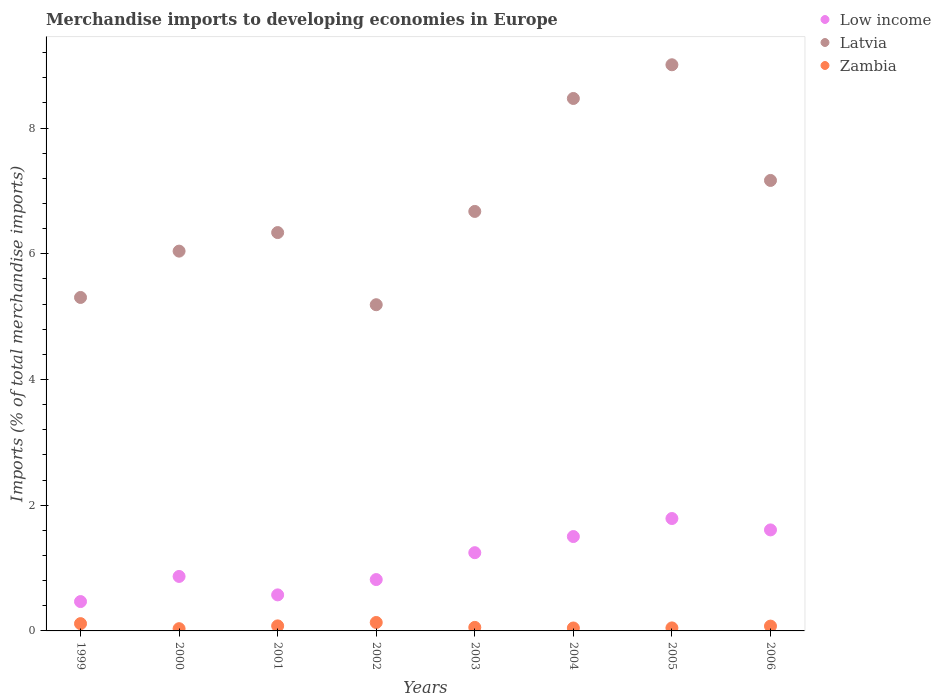Is the number of dotlines equal to the number of legend labels?
Make the answer very short. Yes. What is the percentage total merchandise imports in Latvia in 2005?
Provide a short and direct response. 9.01. Across all years, what is the maximum percentage total merchandise imports in Zambia?
Provide a succinct answer. 0.13. Across all years, what is the minimum percentage total merchandise imports in Low income?
Your answer should be very brief. 0.47. In which year was the percentage total merchandise imports in Low income minimum?
Give a very brief answer. 1999. What is the total percentage total merchandise imports in Low income in the graph?
Offer a terse response. 8.87. What is the difference between the percentage total merchandise imports in Latvia in 2001 and that in 2003?
Provide a succinct answer. -0.34. What is the difference between the percentage total merchandise imports in Zambia in 2002 and the percentage total merchandise imports in Low income in 2005?
Your answer should be compact. -1.65. What is the average percentage total merchandise imports in Latvia per year?
Your answer should be very brief. 6.77. In the year 1999, what is the difference between the percentage total merchandise imports in Latvia and percentage total merchandise imports in Low income?
Make the answer very short. 4.84. In how many years, is the percentage total merchandise imports in Zambia greater than 4.8 %?
Offer a very short reply. 0. What is the ratio of the percentage total merchandise imports in Latvia in 2002 to that in 2006?
Your answer should be compact. 0.72. What is the difference between the highest and the second highest percentage total merchandise imports in Low income?
Keep it short and to the point. 0.18. What is the difference between the highest and the lowest percentage total merchandise imports in Zambia?
Offer a very short reply. 0.1. In how many years, is the percentage total merchandise imports in Low income greater than the average percentage total merchandise imports in Low income taken over all years?
Your answer should be very brief. 4. Is the percentage total merchandise imports in Zambia strictly less than the percentage total merchandise imports in Low income over the years?
Keep it short and to the point. Yes. How many dotlines are there?
Keep it short and to the point. 3. How many years are there in the graph?
Make the answer very short. 8. What is the difference between two consecutive major ticks on the Y-axis?
Keep it short and to the point. 2. Are the values on the major ticks of Y-axis written in scientific E-notation?
Give a very brief answer. No. Does the graph contain any zero values?
Offer a very short reply. No. How are the legend labels stacked?
Provide a short and direct response. Vertical. What is the title of the graph?
Offer a very short reply. Merchandise imports to developing economies in Europe. What is the label or title of the Y-axis?
Your answer should be very brief. Imports (% of total merchandise imports). What is the Imports (% of total merchandise imports) of Low income in 1999?
Ensure brevity in your answer.  0.47. What is the Imports (% of total merchandise imports) in Latvia in 1999?
Ensure brevity in your answer.  5.31. What is the Imports (% of total merchandise imports) of Zambia in 1999?
Your answer should be very brief. 0.12. What is the Imports (% of total merchandise imports) in Low income in 2000?
Make the answer very short. 0.87. What is the Imports (% of total merchandise imports) in Latvia in 2000?
Keep it short and to the point. 6.04. What is the Imports (% of total merchandise imports) in Zambia in 2000?
Make the answer very short. 0.04. What is the Imports (% of total merchandise imports) in Low income in 2001?
Provide a short and direct response. 0.57. What is the Imports (% of total merchandise imports) of Latvia in 2001?
Make the answer very short. 6.34. What is the Imports (% of total merchandise imports) of Zambia in 2001?
Your answer should be compact. 0.08. What is the Imports (% of total merchandise imports) of Low income in 2002?
Offer a very short reply. 0.82. What is the Imports (% of total merchandise imports) of Latvia in 2002?
Ensure brevity in your answer.  5.19. What is the Imports (% of total merchandise imports) of Zambia in 2002?
Provide a short and direct response. 0.13. What is the Imports (% of total merchandise imports) in Low income in 2003?
Keep it short and to the point. 1.24. What is the Imports (% of total merchandise imports) of Latvia in 2003?
Make the answer very short. 6.67. What is the Imports (% of total merchandise imports) in Zambia in 2003?
Ensure brevity in your answer.  0.06. What is the Imports (% of total merchandise imports) of Low income in 2004?
Your answer should be very brief. 1.5. What is the Imports (% of total merchandise imports) of Latvia in 2004?
Offer a very short reply. 8.47. What is the Imports (% of total merchandise imports) of Zambia in 2004?
Provide a short and direct response. 0.05. What is the Imports (% of total merchandise imports) of Low income in 2005?
Offer a terse response. 1.79. What is the Imports (% of total merchandise imports) in Latvia in 2005?
Your answer should be very brief. 9.01. What is the Imports (% of total merchandise imports) in Zambia in 2005?
Your response must be concise. 0.05. What is the Imports (% of total merchandise imports) of Low income in 2006?
Your answer should be compact. 1.61. What is the Imports (% of total merchandise imports) in Latvia in 2006?
Offer a terse response. 7.17. What is the Imports (% of total merchandise imports) of Zambia in 2006?
Give a very brief answer. 0.08. Across all years, what is the maximum Imports (% of total merchandise imports) of Low income?
Your answer should be compact. 1.79. Across all years, what is the maximum Imports (% of total merchandise imports) in Latvia?
Give a very brief answer. 9.01. Across all years, what is the maximum Imports (% of total merchandise imports) of Zambia?
Make the answer very short. 0.13. Across all years, what is the minimum Imports (% of total merchandise imports) of Low income?
Keep it short and to the point. 0.47. Across all years, what is the minimum Imports (% of total merchandise imports) of Latvia?
Make the answer very short. 5.19. Across all years, what is the minimum Imports (% of total merchandise imports) in Zambia?
Your answer should be very brief. 0.04. What is the total Imports (% of total merchandise imports) in Low income in the graph?
Give a very brief answer. 8.87. What is the total Imports (% of total merchandise imports) of Latvia in the graph?
Ensure brevity in your answer.  54.19. What is the total Imports (% of total merchandise imports) of Zambia in the graph?
Make the answer very short. 0.59. What is the difference between the Imports (% of total merchandise imports) in Low income in 1999 and that in 2000?
Provide a short and direct response. -0.4. What is the difference between the Imports (% of total merchandise imports) of Latvia in 1999 and that in 2000?
Offer a very short reply. -0.74. What is the difference between the Imports (% of total merchandise imports) in Zambia in 1999 and that in 2000?
Provide a succinct answer. 0.08. What is the difference between the Imports (% of total merchandise imports) of Low income in 1999 and that in 2001?
Give a very brief answer. -0.11. What is the difference between the Imports (% of total merchandise imports) in Latvia in 1999 and that in 2001?
Your answer should be compact. -1.03. What is the difference between the Imports (% of total merchandise imports) in Zambia in 1999 and that in 2001?
Offer a terse response. 0.04. What is the difference between the Imports (% of total merchandise imports) in Low income in 1999 and that in 2002?
Keep it short and to the point. -0.35. What is the difference between the Imports (% of total merchandise imports) of Latvia in 1999 and that in 2002?
Your answer should be compact. 0.12. What is the difference between the Imports (% of total merchandise imports) in Zambia in 1999 and that in 2002?
Your answer should be very brief. -0.02. What is the difference between the Imports (% of total merchandise imports) in Low income in 1999 and that in 2003?
Give a very brief answer. -0.78. What is the difference between the Imports (% of total merchandise imports) of Latvia in 1999 and that in 2003?
Offer a terse response. -1.37. What is the difference between the Imports (% of total merchandise imports) in Zambia in 1999 and that in 2003?
Ensure brevity in your answer.  0.06. What is the difference between the Imports (% of total merchandise imports) in Low income in 1999 and that in 2004?
Your response must be concise. -1.03. What is the difference between the Imports (% of total merchandise imports) of Latvia in 1999 and that in 2004?
Your answer should be compact. -3.17. What is the difference between the Imports (% of total merchandise imports) in Zambia in 1999 and that in 2004?
Provide a succinct answer. 0.07. What is the difference between the Imports (% of total merchandise imports) in Low income in 1999 and that in 2005?
Provide a succinct answer. -1.32. What is the difference between the Imports (% of total merchandise imports) in Latvia in 1999 and that in 2005?
Provide a short and direct response. -3.7. What is the difference between the Imports (% of total merchandise imports) of Zambia in 1999 and that in 2005?
Your answer should be very brief. 0.07. What is the difference between the Imports (% of total merchandise imports) of Low income in 1999 and that in 2006?
Offer a very short reply. -1.14. What is the difference between the Imports (% of total merchandise imports) in Latvia in 1999 and that in 2006?
Give a very brief answer. -1.86. What is the difference between the Imports (% of total merchandise imports) in Zambia in 1999 and that in 2006?
Your answer should be very brief. 0.04. What is the difference between the Imports (% of total merchandise imports) of Low income in 2000 and that in 2001?
Provide a succinct answer. 0.29. What is the difference between the Imports (% of total merchandise imports) of Latvia in 2000 and that in 2001?
Make the answer very short. -0.3. What is the difference between the Imports (% of total merchandise imports) in Zambia in 2000 and that in 2001?
Give a very brief answer. -0.04. What is the difference between the Imports (% of total merchandise imports) in Low income in 2000 and that in 2002?
Provide a short and direct response. 0.05. What is the difference between the Imports (% of total merchandise imports) of Latvia in 2000 and that in 2002?
Your answer should be very brief. 0.85. What is the difference between the Imports (% of total merchandise imports) of Zambia in 2000 and that in 2002?
Offer a terse response. -0.1. What is the difference between the Imports (% of total merchandise imports) in Low income in 2000 and that in 2003?
Your response must be concise. -0.38. What is the difference between the Imports (% of total merchandise imports) in Latvia in 2000 and that in 2003?
Provide a succinct answer. -0.63. What is the difference between the Imports (% of total merchandise imports) in Zambia in 2000 and that in 2003?
Give a very brief answer. -0.02. What is the difference between the Imports (% of total merchandise imports) of Low income in 2000 and that in 2004?
Provide a short and direct response. -0.63. What is the difference between the Imports (% of total merchandise imports) of Latvia in 2000 and that in 2004?
Your response must be concise. -2.43. What is the difference between the Imports (% of total merchandise imports) of Zambia in 2000 and that in 2004?
Your response must be concise. -0.01. What is the difference between the Imports (% of total merchandise imports) of Low income in 2000 and that in 2005?
Your answer should be compact. -0.92. What is the difference between the Imports (% of total merchandise imports) in Latvia in 2000 and that in 2005?
Provide a short and direct response. -2.96. What is the difference between the Imports (% of total merchandise imports) of Zambia in 2000 and that in 2005?
Offer a very short reply. -0.01. What is the difference between the Imports (% of total merchandise imports) in Low income in 2000 and that in 2006?
Your answer should be very brief. -0.74. What is the difference between the Imports (% of total merchandise imports) in Latvia in 2000 and that in 2006?
Give a very brief answer. -1.12. What is the difference between the Imports (% of total merchandise imports) in Zambia in 2000 and that in 2006?
Ensure brevity in your answer.  -0.04. What is the difference between the Imports (% of total merchandise imports) in Low income in 2001 and that in 2002?
Offer a very short reply. -0.24. What is the difference between the Imports (% of total merchandise imports) of Latvia in 2001 and that in 2002?
Your response must be concise. 1.15. What is the difference between the Imports (% of total merchandise imports) of Zambia in 2001 and that in 2002?
Provide a succinct answer. -0.05. What is the difference between the Imports (% of total merchandise imports) in Low income in 2001 and that in 2003?
Ensure brevity in your answer.  -0.67. What is the difference between the Imports (% of total merchandise imports) in Latvia in 2001 and that in 2003?
Provide a short and direct response. -0.34. What is the difference between the Imports (% of total merchandise imports) in Zambia in 2001 and that in 2003?
Give a very brief answer. 0.02. What is the difference between the Imports (% of total merchandise imports) in Low income in 2001 and that in 2004?
Your answer should be very brief. -0.93. What is the difference between the Imports (% of total merchandise imports) of Latvia in 2001 and that in 2004?
Give a very brief answer. -2.13. What is the difference between the Imports (% of total merchandise imports) of Zambia in 2001 and that in 2004?
Make the answer very short. 0.03. What is the difference between the Imports (% of total merchandise imports) of Low income in 2001 and that in 2005?
Offer a very short reply. -1.22. What is the difference between the Imports (% of total merchandise imports) in Latvia in 2001 and that in 2005?
Ensure brevity in your answer.  -2.67. What is the difference between the Imports (% of total merchandise imports) of Zambia in 2001 and that in 2005?
Keep it short and to the point. 0.03. What is the difference between the Imports (% of total merchandise imports) in Low income in 2001 and that in 2006?
Keep it short and to the point. -1.03. What is the difference between the Imports (% of total merchandise imports) in Latvia in 2001 and that in 2006?
Ensure brevity in your answer.  -0.83. What is the difference between the Imports (% of total merchandise imports) in Zambia in 2001 and that in 2006?
Give a very brief answer. 0. What is the difference between the Imports (% of total merchandise imports) in Low income in 2002 and that in 2003?
Your response must be concise. -0.43. What is the difference between the Imports (% of total merchandise imports) of Latvia in 2002 and that in 2003?
Your answer should be very brief. -1.48. What is the difference between the Imports (% of total merchandise imports) in Zambia in 2002 and that in 2003?
Offer a terse response. 0.08. What is the difference between the Imports (% of total merchandise imports) in Low income in 2002 and that in 2004?
Provide a succinct answer. -0.68. What is the difference between the Imports (% of total merchandise imports) in Latvia in 2002 and that in 2004?
Your answer should be compact. -3.28. What is the difference between the Imports (% of total merchandise imports) in Zambia in 2002 and that in 2004?
Offer a very short reply. 0.09. What is the difference between the Imports (% of total merchandise imports) in Low income in 2002 and that in 2005?
Ensure brevity in your answer.  -0.97. What is the difference between the Imports (% of total merchandise imports) of Latvia in 2002 and that in 2005?
Your answer should be compact. -3.82. What is the difference between the Imports (% of total merchandise imports) of Zambia in 2002 and that in 2005?
Offer a very short reply. 0.09. What is the difference between the Imports (% of total merchandise imports) in Low income in 2002 and that in 2006?
Offer a very short reply. -0.79. What is the difference between the Imports (% of total merchandise imports) of Latvia in 2002 and that in 2006?
Ensure brevity in your answer.  -1.98. What is the difference between the Imports (% of total merchandise imports) of Zambia in 2002 and that in 2006?
Make the answer very short. 0.06. What is the difference between the Imports (% of total merchandise imports) in Low income in 2003 and that in 2004?
Offer a very short reply. -0.26. What is the difference between the Imports (% of total merchandise imports) in Latvia in 2003 and that in 2004?
Offer a terse response. -1.8. What is the difference between the Imports (% of total merchandise imports) in Zambia in 2003 and that in 2004?
Keep it short and to the point. 0.01. What is the difference between the Imports (% of total merchandise imports) of Low income in 2003 and that in 2005?
Provide a short and direct response. -0.54. What is the difference between the Imports (% of total merchandise imports) in Latvia in 2003 and that in 2005?
Offer a very short reply. -2.33. What is the difference between the Imports (% of total merchandise imports) of Zambia in 2003 and that in 2005?
Your answer should be compact. 0.01. What is the difference between the Imports (% of total merchandise imports) of Low income in 2003 and that in 2006?
Give a very brief answer. -0.36. What is the difference between the Imports (% of total merchandise imports) of Latvia in 2003 and that in 2006?
Make the answer very short. -0.49. What is the difference between the Imports (% of total merchandise imports) in Zambia in 2003 and that in 2006?
Make the answer very short. -0.02. What is the difference between the Imports (% of total merchandise imports) in Low income in 2004 and that in 2005?
Your answer should be very brief. -0.29. What is the difference between the Imports (% of total merchandise imports) of Latvia in 2004 and that in 2005?
Your response must be concise. -0.54. What is the difference between the Imports (% of total merchandise imports) of Zambia in 2004 and that in 2005?
Your answer should be compact. -0. What is the difference between the Imports (% of total merchandise imports) in Low income in 2004 and that in 2006?
Provide a succinct answer. -0.11. What is the difference between the Imports (% of total merchandise imports) of Latvia in 2004 and that in 2006?
Your answer should be very brief. 1.3. What is the difference between the Imports (% of total merchandise imports) of Zambia in 2004 and that in 2006?
Your response must be concise. -0.03. What is the difference between the Imports (% of total merchandise imports) of Low income in 2005 and that in 2006?
Provide a succinct answer. 0.18. What is the difference between the Imports (% of total merchandise imports) of Latvia in 2005 and that in 2006?
Make the answer very short. 1.84. What is the difference between the Imports (% of total merchandise imports) in Zambia in 2005 and that in 2006?
Make the answer very short. -0.03. What is the difference between the Imports (% of total merchandise imports) in Low income in 1999 and the Imports (% of total merchandise imports) in Latvia in 2000?
Provide a succinct answer. -5.58. What is the difference between the Imports (% of total merchandise imports) of Low income in 1999 and the Imports (% of total merchandise imports) of Zambia in 2000?
Offer a very short reply. 0.43. What is the difference between the Imports (% of total merchandise imports) of Latvia in 1999 and the Imports (% of total merchandise imports) of Zambia in 2000?
Offer a terse response. 5.27. What is the difference between the Imports (% of total merchandise imports) of Low income in 1999 and the Imports (% of total merchandise imports) of Latvia in 2001?
Give a very brief answer. -5.87. What is the difference between the Imports (% of total merchandise imports) of Low income in 1999 and the Imports (% of total merchandise imports) of Zambia in 2001?
Provide a short and direct response. 0.39. What is the difference between the Imports (% of total merchandise imports) in Latvia in 1999 and the Imports (% of total merchandise imports) in Zambia in 2001?
Give a very brief answer. 5.23. What is the difference between the Imports (% of total merchandise imports) in Low income in 1999 and the Imports (% of total merchandise imports) in Latvia in 2002?
Provide a succinct answer. -4.72. What is the difference between the Imports (% of total merchandise imports) in Low income in 1999 and the Imports (% of total merchandise imports) in Zambia in 2002?
Ensure brevity in your answer.  0.33. What is the difference between the Imports (% of total merchandise imports) in Latvia in 1999 and the Imports (% of total merchandise imports) in Zambia in 2002?
Give a very brief answer. 5.17. What is the difference between the Imports (% of total merchandise imports) in Low income in 1999 and the Imports (% of total merchandise imports) in Latvia in 2003?
Offer a very short reply. -6.21. What is the difference between the Imports (% of total merchandise imports) of Low income in 1999 and the Imports (% of total merchandise imports) of Zambia in 2003?
Your answer should be compact. 0.41. What is the difference between the Imports (% of total merchandise imports) of Latvia in 1999 and the Imports (% of total merchandise imports) of Zambia in 2003?
Give a very brief answer. 5.25. What is the difference between the Imports (% of total merchandise imports) in Low income in 1999 and the Imports (% of total merchandise imports) in Latvia in 2004?
Make the answer very short. -8. What is the difference between the Imports (% of total merchandise imports) in Low income in 1999 and the Imports (% of total merchandise imports) in Zambia in 2004?
Offer a terse response. 0.42. What is the difference between the Imports (% of total merchandise imports) in Latvia in 1999 and the Imports (% of total merchandise imports) in Zambia in 2004?
Offer a terse response. 5.26. What is the difference between the Imports (% of total merchandise imports) of Low income in 1999 and the Imports (% of total merchandise imports) of Latvia in 2005?
Ensure brevity in your answer.  -8.54. What is the difference between the Imports (% of total merchandise imports) of Low income in 1999 and the Imports (% of total merchandise imports) of Zambia in 2005?
Ensure brevity in your answer.  0.42. What is the difference between the Imports (% of total merchandise imports) in Latvia in 1999 and the Imports (% of total merchandise imports) in Zambia in 2005?
Your answer should be very brief. 5.26. What is the difference between the Imports (% of total merchandise imports) of Low income in 1999 and the Imports (% of total merchandise imports) of Latvia in 2006?
Your response must be concise. -6.7. What is the difference between the Imports (% of total merchandise imports) in Low income in 1999 and the Imports (% of total merchandise imports) in Zambia in 2006?
Your response must be concise. 0.39. What is the difference between the Imports (% of total merchandise imports) in Latvia in 1999 and the Imports (% of total merchandise imports) in Zambia in 2006?
Keep it short and to the point. 5.23. What is the difference between the Imports (% of total merchandise imports) of Low income in 2000 and the Imports (% of total merchandise imports) of Latvia in 2001?
Offer a very short reply. -5.47. What is the difference between the Imports (% of total merchandise imports) in Low income in 2000 and the Imports (% of total merchandise imports) in Zambia in 2001?
Your answer should be compact. 0.79. What is the difference between the Imports (% of total merchandise imports) in Latvia in 2000 and the Imports (% of total merchandise imports) in Zambia in 2001?
Offer a terse response. 5.96. What is the difference between the Imports (% of total merchandise imports) of Low income in 2000 and the Imports (% of total merchandise imports) of Latvia in 2002?
Your response must be concise. -4.32. What is the difference between the Imports (% of total merchandise imports) of Low income in 2000 and the Imports (% of total merchandise imports) of Zambia in 2002?
Offer a terse response. 0.73. What is the difference between the Imports (% of total merchandise imports) in Latvia in 2000 and the Imports (% of total merchandise imports) in Zambia in 2002?
Ensure brevity in your answer.  5.91. What is the difference between the Imports (% of total merchandise imports) of Low income in 2000 and the Imports (% of total merchandise imports) of Latvia in 2003?
Provide a succinct answer. -5.81. What is the difference between the Imports (% of total merchandise imports) in Low income in 2000 and the Imports (% of total merchandise imports) in Zambia in 2003?
Offer a very short reply. 0.81. What is the difference between the Imports (% of total merchandise imports) in Latvia in 2000 and the Imports (% of total merchandise imports) in Zambia in 2003?
Your answer should be compact. 5.99. What is the difference between the Imports (% of total merchandise imports) in Low income in 2000 and the Imports (% of total merchandise imports) in Latvia in 2004?
Your answer should be compact. -7.6. What is the difference between the Imports (% of total merchandise imports) in Low income in 2000 and the Imports (% of total merchandise imports) in Zambia in 2004?
Give a very brief answer. 0.82. What is the difference between the Imports (% of total merchandise imports) of Latvia in 2000 and the Imports (% of total merchandise imports) of Zambia in 2004?
Offer a very short reply. 6. What is the difference between the Imports (% of total merchandise imports) of Low income in 2000 and the Imports (% of total merchandise imports) of Latvia in 2005?
Ensure brevity in your answer.  -8.14. What is the difference between the Imports (% of total merchandise imports) in Low income in 2000 and the Imports (% of total merchandise imports) in Zambia in 2005?
Your answer should be very brief. 0.82. What is the difference between the Imports (% of total merchandise imports) in Latvia in 2000 and the Imports (% of total merchandise imports) in Zambia in 2005?
Give a very brief answer. 5.99. What is the difference between the Imports (% of total merchandise imports) in Low income in 2000 and the Imports (% of total merchandise imports) in Latvia in 2006?
Give a very brief answer. -6.3. What is the difference between the Imports (% of total merchandise imports) of Low income in 2000 and the Imports (% of total merchandise imports) of Zambia in 2006?
Your response must be concise. 0.79. What is the difference between the Imports (% of total merchandise imports) of Latvia in 2000 and the Imports (% of total merchandise imports) of Zambia in 2006?
Provide a short and direct response. 5.97. What is the difference between the Imports (% of total merchandise imports) in Low income in 2001 and the Imports (% of total merchandise imports) in Latvia in 2002?
Keep it short and to the point. -4.62. What is the difference between the Imports (% of total merchandise imports) of Low income in 2001 and the Imports (% of total merchandise imports) of Zambia in 2002?
Give a very brief answer. 0.44. What is the difference between the Imports (% of total merchandise imports) in Latvia in 2001 and the Imports (% of total merchandise imports) in Zambia in 2002?
Make the answer very short. 6.2. What is the difference between the Imports (% of total merchandise imports) in Low income in 2001 and the Imports (% of total merchandise imports) in Latvia in 2003?
Provide a short and direct response. -6.1. What is the difference between the Imports (% of total merchandise imports) of Low income in 2001 and the Imports (% of total merchandise imports) of Zambia in 2003?
Offer a terse response. 0.52. What is the difference between the Imports (% of total merchandise imports) of Latvia in 2001 and the Imports (% of total merchandise imports) of Zambia in 2003?
Your answer should be compact. 6.28. What is the difference between the Imports (% of total merchandise imports) in Low income in 2001 and the Imports (% of total merchandise imports) in Latvia in 2004?
Offer a terse response. -7.9. What is the difference between the Imports (% of total merchandise imports) in Low income in 2001 and the Imports (% of total merchandise imports) in Zambia in 2004?
Offer a very short reply. 0.53. What is the difference between the Imports (% of total merchandise imports) of Latvia in 2001 and the Imports (% of total merchandise imports) of Zambia in 2004?
Offer a terse response. 6.29. What is the difference between the Imports (% of total merchandise imports) in Low income in 2001 and the Imports (% of total merchandise imports) in Latvia in 2005?
Your response must be concise. -8.43. What is the difference between the Imports (% of total merchandise imports) of Low income in 2001 and the Imports (% of total merchandise imports) of Zambia in 2005?
Provide a short and direct response. 0.53. What is the difference between the Imports (% of total merchandise imports) in Latvia in 2001 and the Imports (% of total merchandise imports) in Zambia in 2005?
Your answer should be very brief. 6.29. What is the difference between the Imports (% of total merchandise imports) of Low income in 2001 and the Imports (% of total merchandise imports) of Latvia in 2006?
Provide a short and direct response. -6.59. What is the difference between the Imports (% of total merchandise imports) of Low income in 2001 and the Imports (% of total merchandise imports) of Zambia in 2006?
Make the answer very short. 0.5. What is the difference between the Imports (% of total merchandise imports) in Latvia in 2001 and the Imports (% of total merchandise imports) in Zambia in 2006?
Your answer should be very brief. 6.26. What is the difference between the Imports (% of total merchandise imports) of Low income in 2002 and the Imports (% of total merchandise imports) of Latvia in 2003?
Keep it short and to the point. -5.86. What is the difference between the Imports (% of total merchandise imports) of Low income in 2002 and the Imports (% of total merchandise imports) of Zambia in 2003?
Your response must be concise. 0.76. What is the difference between the Imports (% of total merchandise imports) in Latvia in 2002 and the Imports (% of total merchandise imports) in Zambia in 2003?
Make the answer very short. 5.13. What is the difference between the Imports (% of total merchandise imports) in Low income in 2002 and the Imports (% of total merchandise imports) in Latvia in 2004?
Ensure brevity in your answer.  -7.65. What is the difference between the Imports (% of total merchandise imports) in Low income in 2002 and the Imports (% of total merchandise imports) in Zambia in 2004?
Ensure brevity in your answer.  0.77. What is the difference between the Imports (% of total merchandise imports) in Latvia in 2002 and the Imports (% of total merchandise imports) in Zambia in 2004?
Your answer should be compact. 5.14. What is the difference between the Imports (% of total merchandise imports) of Low income in 2002 and the Imports (% of total merchandise imports) of Latvia in 2005?
Provide a short and direct response. -8.19. What is the difference between the Imports (% of total merchandise imports) of Low income in 2002 and the Imports (% of total merchandise imports) of Zambia in 2005?
Make the answer very short. 0.77. What is the difference between the Imports (% of total merchandise imports) of Latvia in 2002 and the Imports (% of total merchandise imports) of Zambia in 2005?
Your answer should be compact. 5.14. What is the difference between the Imports (% of total merchandise imports) of Low income in 2002 and the Imports (% of total merchandise imports) of Latvia in 2006?
Your response must be concise. -6.35. What is the difference between the Imports (% of total merchandise imports) of Low income in 2002 and the Imports (% of total merchandise imports) of Zambia in 2006?
Your response must be concise. 0.74. What is the difference between the Imports (% of total merchandise imports) of Latvia in 2002 and the Imports (% of total merchandise imports) of Zambia in 2006?
Ensure brevity in your answer.  5.11. What is the difference between the Imports (% of total merchandise imports) of Low income in 2003 and the Imports (% of total merchandise imports) of Latvia in 2004?
Your answer should be compact. -7.23. What is the difference between the Imports (% of total merchandise imports) of Low income in 2003 and the Imports (% of total merchandise imports) of Zambia in 2004?
Your answer should be compact. 1.2. What is the difference between the Imports (% of total merchandise imports) of Latvia in 2003 and the Imports (% of total merchandise imports) of Zambia in 2004?
Your answer should be compact. 6.63. What is the difference between the Imports (% of total merchandise imports) of Low income in 2003 and the Imports (% of total merchandise imports) of Latvia in 2005?
Provide a short and direct response. -7.76. What is the difference between the Imports (% of total merchandise imports) in Low income in 2003 and the Imports (% of total merchandise imports) in Zambia in 2005?
Your answer should be compact. 1.2. What is the difference between the Imports (% of total merchandise imports) in Latvia in 2003 and the Imports (% of total merchandise imports) in Zambia in 2005?
Make the answer very short. 6.63. What is the difference between the Imports (% of total merchandise imports) in Low income in 2003 and the Imports (% of total merchandise imports) in Latvia in 2006?
Provide a succinct answer. -5.92. What is the difference between the Imports (% of total merchandise imports) in Low income in 2003 and the Imports (% of total merchandise imports) in Zambia in 2006?
Ensure brevity in your answer.  1.17. What is the difference between the Imports (% of total merchandise imports) in Latvia in 2003 and the Imports (% of total merchandise imports) in Zambia in 2006?
Provide a succinct answer. 6.6. What is the difference between the Imports (% of total merchandise imports) of Low income in 2004 and the Imports (% of total merchandise imports) of Latvia in 2005?
Give a very brief answer. -7.51. What is the difference between the Imports (% of total merchandise imports) in Low income in 2004 and the Imports (% of total merchandise imports) in Zambia in 2005?
Your answer should be very brief. 1.45. What is the difference between the Imports (% of total merchandise imports) in Latvia in 2004 and the Imports (% of total merchandise imports) in Zambia in 2005?
Your response must be concise. 8.42. What is the difference between the Imports (% of total merchandise imports) of Low income in 2004 and the Imports (% of total merchandise imports) of Latvia in 2006?
Provide a short and direct response. -5.67. What is the difference between the Imports (% of total merchandise imports) of Low income in 2004 and the Imports (% of total merchandise imports) of Zambia in 2006?
Keep it short and to the point. 1.42. What is the difference between the Imports (% of total merchandise imports) in Latvia in 2004 and the Imports (% of total merchandise imports) in Zambia in 2006?
Offer a very short reply. 8.39. What is the difference between the Imports (% of total merchandise imports) in Low income in 2005 and the Imports (% of total merchandise imports) in Latvia in 2006?
Offer a very short reply. -5.38. What is the difference between the Imports (% of total merchandise imports) in Low income in 2005 and the Imports (% of total merchandise imports) in Zambia in 2006?
Offer a very short reply. 1.71. What is the difference between the Imports (% of total merchandise imports) in Latvia in 2005 and the Imports (% of total merchandise imports) in Zambia in 2006?
Keep it short and to the point. 8.93. What is the average Imports (% of total merchandise imports) of Low income per year?
Provide a succinct answer. 1.11. What is the average Imports (% of total merchandise imports) in Latvia per year?
Give a very brief answer. 6.77. What is the average Imports (% of total merchandise imports) in Zambia per year?
Your response must be concise. 0.07. In the year 1999, what is the difference between the Imports (% of total merchandise imports) in Low income and Imports (% of total merchandise imports) in Latvia?
Offer a very short reply. -4.84. In the year 1999, what is the difference between the Imports (% of total merchandise imports) in Low income and Imports (% of total merchandise imports) in Zambia?
Provide a succinct answer. 0.35. In the year 1999, what is the difference between the Imports (% of total merchandise imports) of Latvia and Imports (% of total merchandise imports) of Zambia?
Offer a very short reply. 5.19. In the year 2000, what is the difference between the Imports (% of total merchandise imports) of Low income and Imports (% of total merchandise imports) of Latvia?
Make the answer very short. -5.18. In the year 2000, what is the difference between the Imports (% of total merchandise imports) in Low income and Imports (% of total merchandise imports) in Zambia?
Make the answer very short. 0.83. In the year 2000, what is the difference between the Imports (% of total merchandise imports) in Latvia and Imports (% of total merchandise imports) in Zambia?
Your response must be concise. 6.01. In the year 2001, what is the difference between the Imports (% of total merchandise imports) in Low income and Imports (% of total merchandise imports) in Latvia?
Ensure brevity in your answer.  -5.76. In the year 2001, what is the difference between the Imports (% of total merchandise imports) of Low income and Imports (% of total merchandise imports) of Zambia?
Your answer should be very brief. 0.49. In the year 2001, what is the difference between the Imports (% of total merchandise imports) of Latvia and Imports (% of total merchandise imports) of Zambia?
Make the answer very short. 6.26. In the year 2002, what is the difference between the Imports (% of total merchandise imports) in Low income and Imports (% of total merchandise imports) in Latvia?
Provide a succinct answer. -4.37. In the year 2002, what is the difference between the Imports (% of total merchandise imports) of Low income and Imports (% of total merchandise imports) of Zambia?
Your answer should be very brief. 0.68. In the year 2002, what is the difference between the Imports (% of total merchandise imports) of Latvia and Imports (% of total merchandise imports) of Zambia?
Make the answer very short. 5.06. In the year 2003, what is the difference between the Imports (% of total merchandise imports) of Low income and Imports (% of total merchandise imports) of Latvia?
Offer a very short reply. -5.43. In the year 2003, what is the difference between the Imports (% of total merchandise imports) in Low income and Imports (% of total merchandise imports) in Zambia?
Give a very brief answer. 1.19. In the year 2003, what is the difference between the Imports (% of total merchandise imports) in Latvia and Imports (% of total merchandise imports) in Zambia?
Provide a succinct answer. 6.62. In the year 2004, what is the difference between the Imports (% of total merchandise imports) of Low income and Imports (% of total merchandise imports) of Latvia?
Your response must be concise. -6.97. In the year 2004, what is the difference between the Imports (% of total merchandise imports) of Low income and Imports (% of total merchandise imports) of Zambia?
Offer a terse response. 1.45. In the year 2004, what is the difference between the Imports (% of total merchandise imports) in Latvia and Imports (% of total merchandise imports) in Zambia?
Your response must be concise. 8.42. In the year 2005, what is the difference between the Imports (% of total merchandise imports) in Low income and Imports (% of total merchandise imports) in Latvia?
Make the answer very short. -7.22. In the year 2005, what is the difference between the Imports (% of total merchandise imports) in Low income and Imports (% of total merchandise imports) in Zambia?
Your response must be concise. 1.74. In the year 2005, what is the difference between the Imports (% of total merchandise imports) of Latvia and Imports (% of total merchandise imports) of Zambia?
Keep it short and to the point. 8.96. In the year 2006, what is the difference between the Imports (% of total merchandise imports) of Low income and Imports (% of total merchandise imports) of Latvia?
Give a very brief answer. -5.56. In the year 2006, what is the difference between the Imports (% of total merchandise imports) in Low income and Imports (% of total merchandise imports) in Zambia?
Your response must be concise. 1.53. In the year 2006, what is the difference between the Imports (% of total merchandise imports) in Latvia and Imports (% of total merchandise imports) in Zambia?
Keep it short and to the point. 7.09. What is the ratio of the Imports (% of total merchandise imports) of Low income in 1999 to that in 2000?
Provide a succinct answer. 0.54. What is the ratio of the Imports (% of total merchandise imports) in Latvia in 1999 to that in 2000?
Make the answer very short. 0.88. What is the ratio of the Imports (% of total merchandise imports) in Zambia in 1999 to that in 2000?
Keep it short and to the point. 3.24. What is the ratio of the Imports (% of total merchandise imports) in Low income in 1999 to that in 2001?
Keep it short and to the point. 0.81. What is the ratio of the Imports (% of total merchandise imports) in Latvia in 1999 to that in 2001?
Your answer should be compact. 0.84. What is the ratio of the Imports (% of total merchandise imports) in Zambia in 1999 to that in 2001?
Your answer should be very brief. 1.45. What is the ratio of the Imports (% of total merchandise imports) of Low income in 1999 to that in 2002?
Your response must be concise. 0.57. What is the ratio of the Imports (% of total merchandise imports) in Latvia in 1999 to that in 2002?
Provide a short and direct response. 1.02. What is the ratio of the Imports (% of total merchandise imports) of Zambia in 1999 to that in 2002?
Provide a succinct answer. 0.86. What is the ratio of the Imports (% of total merchandise imports) of Low income in 1999 to that in 2003?
Your response must be concise. 0.38. What is the ratio of the Imports (% of total merchandise imports) of Latvia in 1999 to that in 2003?
Offer a terse response. 0.79. What is the ratio of the Imports (% of total merchandise imports) of Zambia in 1999 to that in 2003?
Your answer should be compact. 2.07. What is the ratio of the Imports (% of total merchandise imports) of Low income in 1999 to that in 2004?
Your answer should be very brief. 0.31. What is the ratio of the Imports (% of total merchandise imports) in Latvia in 1999 to that in 2004?
Your response must be concise. 0.63. What is the ratio of the Imports (% of total merchandise imports) of Zambia in 1999 to that in 2004?
Offer a terse response. 2.49. What is the ratio of the Imports (% of total merchandise imports) of Low income in 1999 to that in 2005?
Ensure brevity in your answer.  0.26. What is the ratio of the Imports (% of total merchandise imports) of Latvia in 1999 to that in 2005?
Offer a very short reply. 0.59. What is the ratio of the Imports (% of total merchandise imports) in Zambia in 1999 to that in 2005?
Provide a short and direct response. 2.42. What is the ratio of the Imports (% of total merchandise imports) of Low income in 1999 to that in 2006?
Your answer should be compact. 0.29. What is the ratio of the Imports (% of total merchandise imports) of Latvia in 1999 to that in 2006?
Provide a succinct answer. 0.74. What is the ratio of the Imports (% of total merchandise imports) of Zambia in 1999 to that in 2006?
Offer a very short reply. 1.51. What is the ratio of the Imports (% of total merchandise imports) in Low income in 2000 to that in 2001?
Provide a short and direct response. 1.51. What is the ratio of the Imports (% of total merchandise imports) of Latvia in 2000 to that in 2001?
Give a very brief answer. 0.95. What is the ratio of the Imports (% of total merchandise imports) in Zambia in 2000 to that in 2001?
Give a very brief answer. 0.45. What is the ratio of the Imports (% of total merchandise imports) of Low income in 2000 to that in 2002?
Provide a short and direct response. 1.06. What is the ratio of the Imports (% of total merchandise imports) in Latvia in 2000 to that in 2002?
Offer a terse response. 1.16. What is the ratio of the Imports (% of total merchandise imports) of Zambia in 2000 to that in 2002?
Offer a very short reply. 0.27. What is the ratio of the Imports (% of total merchandise imports) in Low income in 2000 to that in 2003?
Provide a succinct answer. 0.7. What is the ratio of the Imports (% of total merchandise imports) of Latvia in 2000 to that in 2003?
Make the answer very short. 0.91. What is the ratio of the Imports (% of total merchandise imports) of Zambia in 2000 to that in 2003?
Provide a succinct answer. 0.64. What is the ratio of the Imports (% of total merchandise imports) in Low income in 2000 to that in 2004?
Keep it short and to the point. 0.58. What is the ratio of the Imports (% of total merchandise imports) of Latvia in 2000 to that in 2004?
Give a very brief answer. 0.71. What is the ratio of the Imports (% of total merchandise imports) of Zambia in 2000 to that in 2004?
Make the answer very short. 0.77. What is the ratio of the Imports (% of total merchandise imports) in Low income in 2000 to that in 2005?
Provide a short and direct response. 0.48. What is the ratio of the Imports (% of total merchandise imports) of Latvia in 2000 to that in 2005?
Your answer should be compact. 0.67. What is the ratio of the Imports (% of total merchandise imports) of Zambia in 2000 to that in 2005?
Offer a terse response. 0.75. What is the ratio of the Imports (% of total merchandise imports) of Low income in 2000 to that in 2006?
Keep it short and to the point. 0.54. What is the ratio of the Imports (% of total merchandise imports) of Latvia in 2000 to that in 2006?
Your answer should be compact. 0.84. What is the ratio of the Imports (% of total merchandise imports) of Zambia in 2000 to that in 2006?
Give a very brief answer. 0.47. What is the ratio of the Imports (% of total merchandise imports) in Low income in 2001 to that in 2002?
Offer a very short reply. 0.7. What is the ratio of the Imports (% of total merchandise imports) of Latvia in 2001 to that in 2002?
Your answer should be very brief. 1.22. What is the ratio of the Imports (% of total merchandise imports) of Zambia in 2001 to that in 2002?
Keep it short and to the point. 0.6. What is the ratio of the Imports (% of total merchandise imports) of Low income in 2001 to that in 2003?
Provide a short and direct response. 0.46. What is the ratio of the Imports (% of total merchandise imports) of Latvia in 2001 to that in 2003?
Your answer should be very brief. 0.95. What is the ratio of the Imports (% of total merchandise imports) of Zambia in 2001 to that in 2003?
Your answer should be very brief. 1.43. What is the ratio of the Imports (% of total merchandise imports) in Low income in 2001 to that in 2004?
Ensure brevity in your answer.  0.38. What is the ratio of the Imports (% of total merchandise imports) of Latvia in 2001 to that in 2004?
Give a very brief answer. 0.75. What is the ratio of the Imports (% of total merchandise imports) of Zambia in 2001 to that in 2004?
Provide a short and direct response. 1.72. What is the ratio of the Imports (% of total merchandise imports) in Low income in 2001 to that in 2005?
Offer a very short reply. 0.32. What is the ratio of the Imports (% of total merchandise imports) in Latvia in 2001 to that in 2005?
Ensure brevity in your answer.  0.7. What is the ratio of the Imports (% of total merchandise imports) of Zambia in 2001 to that in 2005?
Give a very brief answer. 1.67. What is the ratio of the Imports (% of total merchandise imports) in Low income in 2001 to that in 2006?
Make the answer very short. 0.36. What is the ratio of the Imports (% of total merchandise imports) of Latvia in 2001 to that in 2006?
Provide a succinct answer. 0.88. What is the ratio of the Imports (% of total merchandise imports) of Zambia in 2001 to that in 2006?
Your response must be concise. 1.04. What is the ratio of the Imports (% of total merchandise imports) of Low income in 2002 to that in 2003?
Your answer should be compact. 0.66. What is the ratio of the Imports (% of total merchandise imports) in Latvia in 2002 to that in 2003?
Your response must be concise. 0.78. What is the ratio of the Imports (% of total merchandise imports) in Zambia in 2002 to that in 2003?
Make the answer very short. 2.39. What is the ratio of the Imports (% of total merchandise imports) of Low income in 2002 to that in 2004?
Keep it short and to the point. 0.54. What is the ratio of the Imports (% of total merchandise imports) of Latvia in 2002 to that in 2004?
Provide a succinct answer. 0.61. What is the ratio of the Imports (% of total merchandise imports) of Zambia in 2002 to that in 2004?
Your answer should be very brief. 2.88. What is the ratio of the Imports (% of total merchandise imports) of Low income in 2002 to that in 2005?
Provide a short and direct response. 0.46. What is the ratio of the Imports (% of total merchandise imports) of Latvia in 2002 to that in 2005?
Offer a terse response. 0.58. What is the ratio of the Imports (% of total merchandise imports) of Zambia in 2002 to that in 2005?
Provide a short and direct response. 2.8. What is the ratio of the Imports (% of total merchandise imports) of Low income in 2002 to that in 2006?
Ensure brevity in your answer.  0.51. What is the ratio of the Imports (% of total merchandise imports) of Latvia in 2002 to that in 2006?
Your answer should be compact. 0.72. What is the ratio of the Imports (% of total merchandise imports) of Zambia in 2002 to that in 2006?
Provide a short and direct response. 1.75. What is the ratio of the Imports (% of total merchandise imports) in Low income in 2003 to that in 2004?
Ensure brevity in your answer.  0.83. What is the ratio of the Imports (% of total merchandise imports) in Latvia in 2003 to that in 2004?
Provide a succinct answer. 0.79. What is the ratio of the Imports (% of total merchandise imports) of Zambia in 2003 to that in 2004?
Ensure brevity in your answer.  1.2. What is the ratio of the Imports (% of total merchandise imports) in Low income in 2003 to that in 2005?
Provide a succinct answer. 0.7. What is the ratio of the Imports (% of total merchandise imports) of Latvia in 2003 to that in 2005?
Your answer should be very brief. 0.74. What is the ratio of the Imports (% of total merchandise imports) in Zambia in 2003 to that in 2005?
Offer a very short reply. 1.17. What is the ratio of the Imports (% of total merchandise imports) in Low income in 2003 to that in 2006?
Make the answer very short. 0.77. What is the ratio of the Imports (% of total merchandise imports) of Latvia in 2003 to that in 2006?
Provide a succinct answer. 0.93. What is the ratio of the Imports (% of total merchandise imports) in Zambia in 2003 to that in 2006?
Provide a short and direct response. 0.73. What is the ratio of the Imports (% of total merchandise imports) of Low income in 2004 to that in 2005?
Offer a terse response. 0.84. What is the ratio of the Imports (% of total merchandise imports) in Latvia in 2004 to that in 2005?
Give a very brief answer. 0.94. What is the ratio of the Imports (% of total merchandise imports) of Zambia in 2004 to that in 2005?
Give a very brief answer. 0.97. What is the ratio of the Imports (% of total merchandise imports) in Low income in 2004 to that in 2006?
Offer a very short reply. 0.93. What is the ratio of the Imports (% of total merchandise imports) in Latvia in 2004 to that in 2006?
Offer a terse response. 1.18. What is the ratio of the Imports (% of total merchandise imports) in Zambia in 2004 to that in 2006?
Offer a terse response. 0.61. What is the ratio of the Imports (% of total merchandise imports) in Low income in 2005 to that in 2006?
Ensure brevity in your answer.  1.11. What is the ratio of the Imports (% of total merchandise imports) of Latvia in 2005 to that in 2006?
Provide a succinct answer. 1.26. What is the ratio of the Imports (% of total merchandise imports) in Zambia in 2005 to that in 2006?
Make the answer very short. 0.62. What is the difference between the highest and the second highest Imports (% of total merchandise imports) in Low income?
Ensure brevity in your answer.  0.18. What is the difference between the highest and the second highest Imports (% of total merchandise imports) in Latvia?
Make the answer very short. 0.54. What is the difference between the highest and the second highest Imports (% of total merchandise imports) in Zambia?
Provide a succinct answer. 0.02. What is the difference between the highest and the lowest Imports (% of total merchandise imports) of Low income?
Offer a very short reply. 1.32. What is the difference between the highest and the lowest Imports (% of total merchandise imports) of Latvia?
Your answer should be very brief. 3.82. What is the difference between the highest and the lowest Imports (% of total merchandise imports) in Zambia?
Provide a short and direct response. 0.1. 